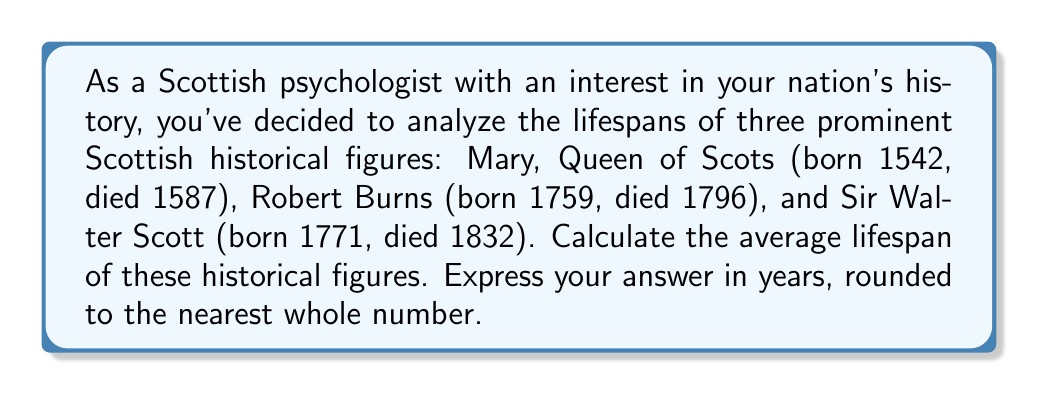Show me your answer to this math problem. To solve this problem, we'll follow these steps:

1. Calculate the lifespan of each historical figure:
   
   a) Mary, Queen of Scots:
      $1587 - 1542 = 45$ years
   
   b) Robert Burns:
      $1796 - 1759 = 37$ years
   
   c) Sir Walter Scott:
      $1832 - 1771 = 61$ years

2. Calculate the average lifespan:
   
   The formula for average is:
   $$\text{Average} = \frac{\text{Sum of all values}}{\text{Number of values}}$$

   In this case:
   $$\text{Average Lifespan} = \frac{45 + 37 + 61}{3}$$

   $$= \frac{143}{3}$$
   
   $$= 47.6666...$$

3. Round to the nearest whole number:
   47.6666... rounds to 48

Therefore, the average lifespan of these three Scottish historical figures is 48 years.
Answer: 48 years 